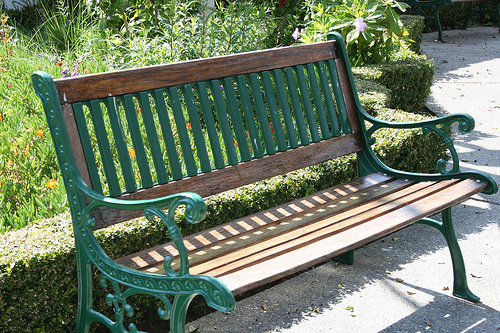What might be the best time of day to enjoy sitting on this bench? Considering the lush garden surroundings and the position of the bench, the best time to enjoy it would likely be in the early morning when the air is fresh and cool or in the late afternoon when the sunlight is warm and golden, casting a beautiful light on the garden and providing a peaceful atmosphere. 